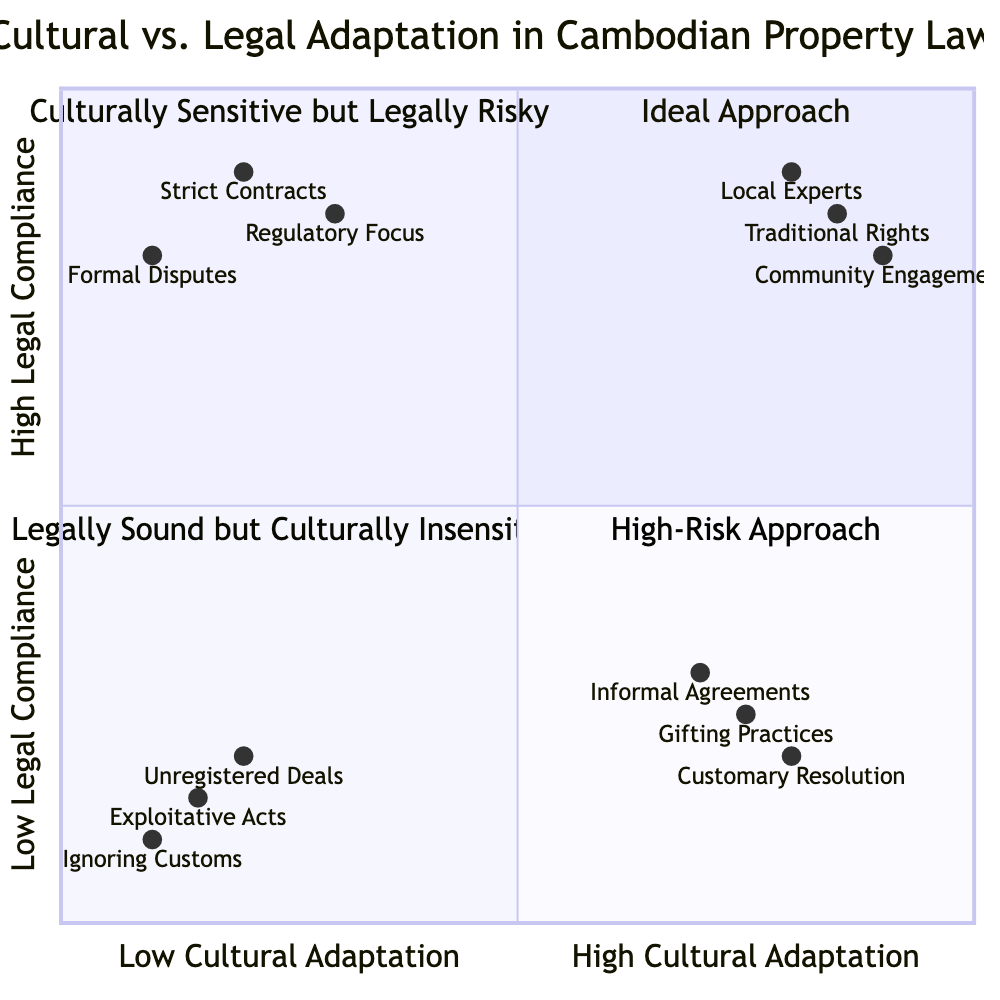What does the "High Cultural Adaptation, High Legal Compliance" quadrant emphasize? The quadrant emphasizes strategies that engage local legal experts, build community relationships, and respect traditional land rights, ensuring smooth property transactions.
Answer: Strategies for smooth property transactions Which element is positioned in the "Low Cultural Adaptation, Low Legal Compliance" quadrant? The element "Ignoring Local Practices" is located in the quadrant, indicating actions that do not align with either cultural expectations or legal requirements.
Answer: Ignoring Local Practices How many elements are included in the "High Cultural Adaptation, Low Legal Compliance" quadrant? There are three elements listed in the quadrant: Informal Agreements, Customary Conflict Resolution, and Gifting Practices.
Answer: Three elements What is the y-axis scale of the quadrant chart? The y-axis scale goes from Low Legal Compliance at the bottom to High Legal Compliance at the top, representing the compliance levels with legal frameworks.
Answer: Low to High Which element has the highest value in both cultural adaptation and legal compliance? The element "Community Engagement" has values of 0.9 for cultural adaptation and 0.8 for legal compliance, indicating strong alignment on both aspects.
Answer: Community Engagement What is the main risk associated with the "Low Cultural Adaptation, High Legal Compliance" quadrant? The risk mainly involves social friction due to strict contract enforcement and formal dispute resolution methods that ignore local customs.
Answer: Social friction Does the element "Unregistered Transactions" appear in a high-compliance quadrant? No, "Unregistered Transactions" appears in the "Low Cultural Adaptation, Low Legal Compliance" quadrant, indicating a lack of adherence to both cultural norms and legal frameworks.
Answer: No Which quadrant represents strategies that may align with Cambodian culture but conflict with formal legal requirements? The quadrant labeled "Culturally Sensitive but Legally Risky" corresponds directly to strategies that relate culturally but may face legal issues.
Answer: Culturally Sensitive but Legally Risky What is the position vector for "Strict Contract Enforcement"? The position for "Strict Contract Enforcement" is [0.2, 0.9], indicating it is located in the Low Cultural Adaptation and High Legal Compliance quadrant.
Answer: [0.2, 0.9] 